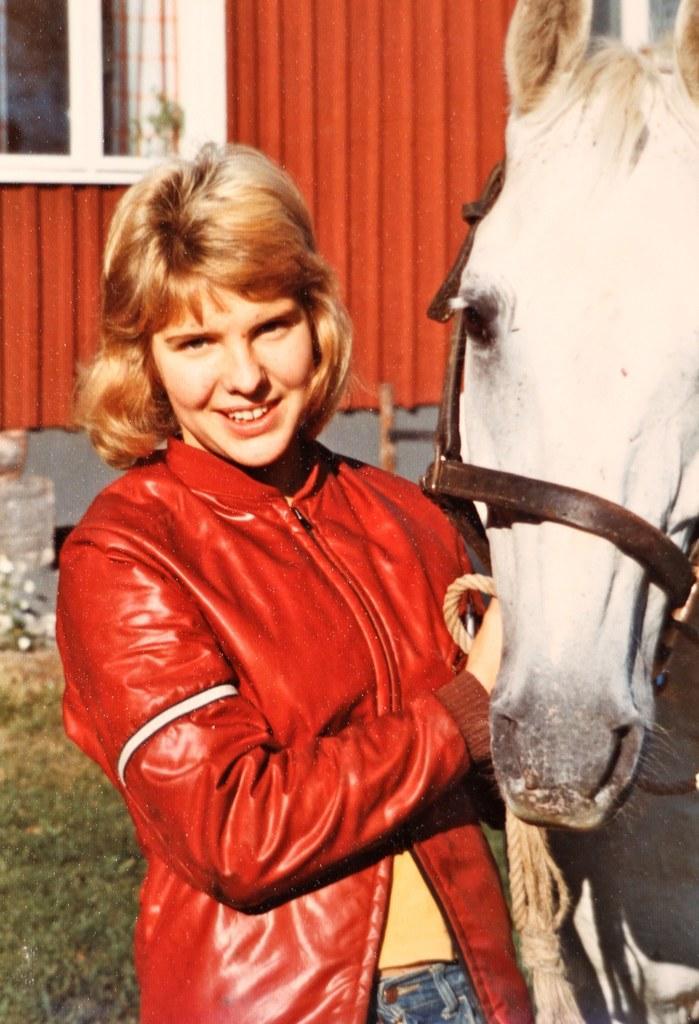How would you summarize this image in a sentence or two? In the image we can see there is a person who is standing and beside the person there is a horse. 